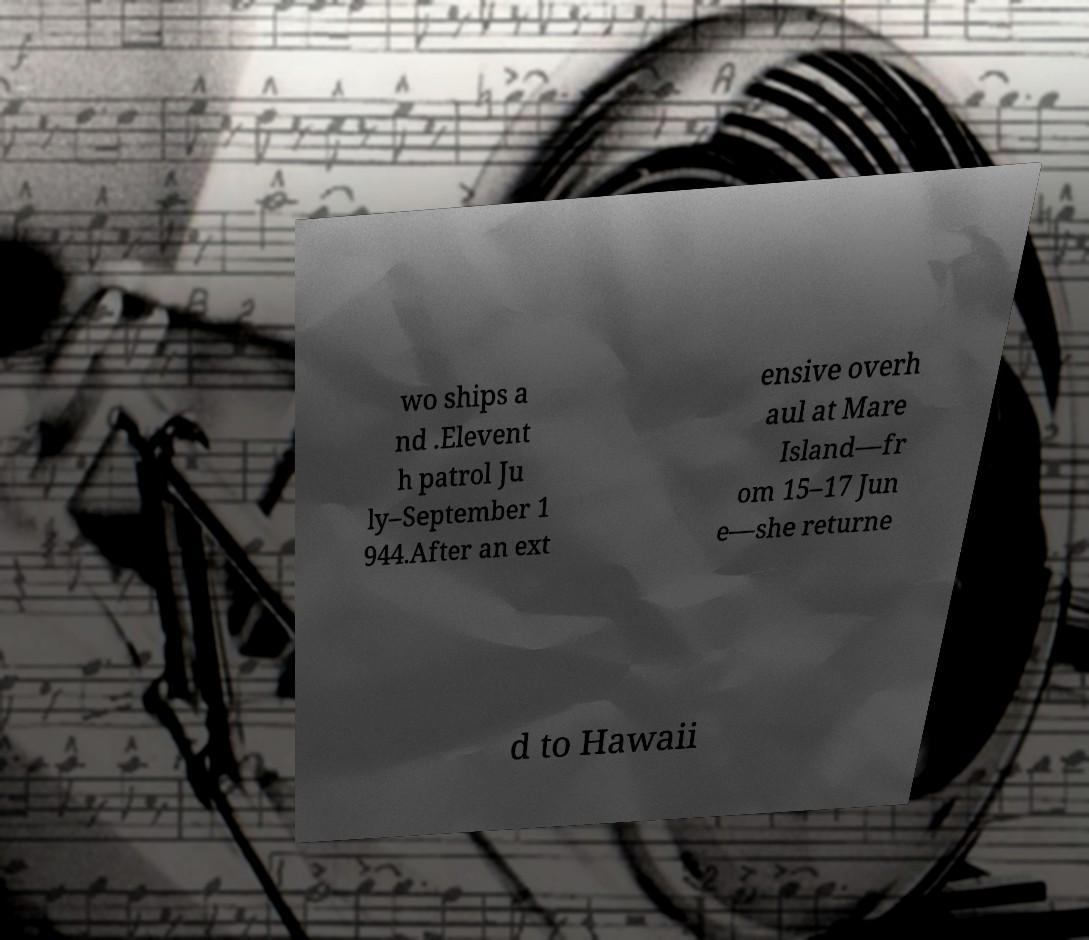There's text embedded in this image that I need extracted. Can you transcribe it verbatim? wo ships a nd .Elevent h patrol Ju ly–September 1 944.After an ext ensive overh aul at Mare Island—fr om 15–17 Jun e—she returne d to Hawaii 